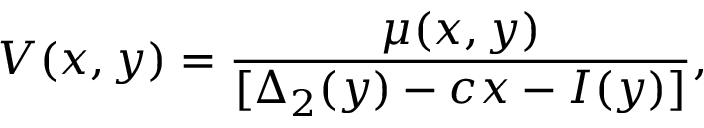Convert formula to latex. <formula><loc_0><loc_0><loc_500><loc_500>V ( x , y ) = \frac { \mu ( x , y ) } { [ \Delta _ { 2 } ( y ) - c x - I ( y ) ] } ,</formula> 